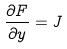Convert formula to latex. <formula><loc_0><loc_0><loc_500><loc_500>\frac { \partial F } { \partial y } = J</formula> 